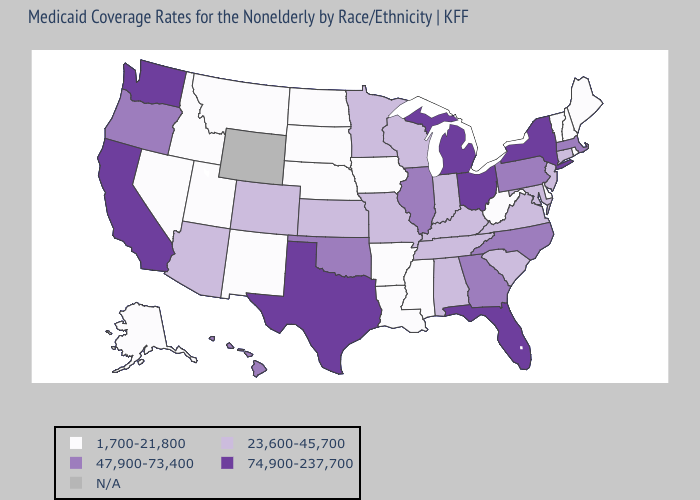What is the value of Oklahoma?
Write a very short answer. 47,900-73,400. Does Maine have the lowest value in the Northeast?
Short answer required. Yes. What is the lowest value in the USA?
Write a very short answer. 1,700-21,800. How many symbols are there in the legend?
Give a very brief answer. 5. Does Idaho have the lowest value in the West?
Keep it brief. Yes. Which states hav the highest value in the Northeast?
Keep it brief. New York. Does North Dakota have the highest value in the MidWest?
Concise answer only. No. What is the value of New Mexico?
Concise answer only. 1,700-21,800. Among the states that border New Jersey , does New York have the highest value?
Be succinct. Yes. Name the states that have a value in the range N/A?
Write a very short answer. Wyoming. Which states have the highest value in the USA?
Concise answer only. California, Florida, Michigan, New York, Ohio, Texas, Washington. Which states hav the highest value in the MidWest?
Short answer required. Michigan, Ohio. Does Delaware have the highest value in the USA?
Keep it brief. No. 